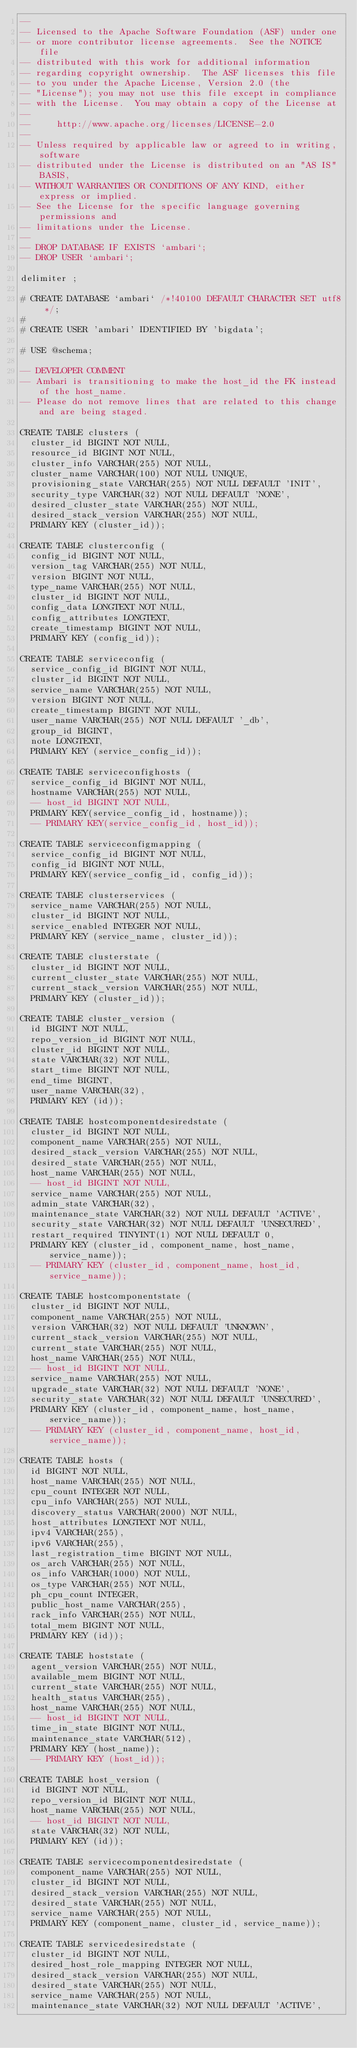<code> <loc_0><loc_0><loc_500><loc_500><_SQL_>--
-- Licensed to the Apache Software Foundation (ASF) under one
-- or more contributor license agreements.  See the NOTICE file
-- distributed with this work for additional information
-- regarding copyright ownership.  The ASF licenses this file
-- to you under the Apache License, Version 2.0 (the
-- "License"); you may not use this file except in compliance
-- with the License.  You may obtain a copy of the License at
--
--     http://www.apache.org/licenses/LICENSE-2.0
--
-- Unless required by applicable law or agreed to in writing, software
-- distributed under the License is distributed on an "AS IS" BASIS,
-- WITHOUT WARRANTIES OR CONDITIONS OF ANY KIND, either express or implied.
-- See the License for the specific language governing permissions and
-- limitations under the License.
--
-- DROP DATABASE IF EXISTS `ambari`;
-- DROP USER `ambari`;

delimiter ;

# CREATE DATABASE `ambari` /*!40100 DEFAULT CHARACTER SET utf8 */;
#
# CREATE USER 'ambari' IDENTIFIED BY 'bigdata';

# USE @schema;

-- DEVELOPER COMMENT
-- Ambari is transitioning to make the host_id the FK instead of the host_name.
-- Please do not remove lines that are related to this change and are being staged.

CREATE TABLE clusters (
  cluster_id BIGINT NOT NULL,
  resource_id BIGINT NOT NULL,
  cluster_info VARCHAR(255) NOT NULL,
  cluster_name VARCHAR(100) NOT NULL UNIQUE,
  provisioning_state VARCHAR(255) NOT NULL DEFAULT 'INIT',
  security_type VARCHAR(32) NOT NULL DEFAULT 'NONE',
  desired_cluster_state VARCHAR(255) NOT NULL,
  desired_stack_version VARCHAR(255) NOT NULL,
  PRIMARY KEY (cluster_id));

CREATE TABLE clusterconfig (
  config_id BIGINT NOT NULL,
  version_tag VARCHAR(255) NOT NULL,
  version BIGINT NOT NULL,
  type_name VARCHAR(255) NOT NULL,
  cluster_id BIGINT NOT NULL,
  config_data LONGTEXT NOT NULL,
  config_attributes LONGTEXT,
  create_timestamp BIGINT NOT NULL,
  PRIMARY KEY (config_id));

CREATE TABLE serviceconfig (
  service_config_id BIGINT NOT NULL,
  cluster_id BIGINT NOT NULL,
  service_name VARCHAR(255) NOT NULL,
  version BIGINT NOT NULL,
  create_timestamp BIGINT NOT NULL,
  user_name VARCHAR(255) NOT NULL DEFAULT '_db',
  group_id BIGINT,
  note LONGTEXT,
  PRIMARY KEY (service_config_id));

CREATE TABLE serviceconfighosts (
  service_config_id BIGINT NOT NULL,
  hostname VARCHAR(255) NOT NULL,
  -- host_id BIGINT NOT NULL,
  PRIMARY KEY(service_config_id, hostname));
  -- PRIMARY KEY(service_config_id, host_id));

CREATE TABLE serviceconfigmapping (
  service_config_id BIGINT NOT NULL,
  config_id BIGINT NOT NULL,
  PRIMARY KEY(service_config_id, config_id));

CREATE TABLE clusterservices (
  service_name VARCHAR(255) NOT NULL,
  cluster_id BIGINT NOT NULL,
  service_enabled INTEGER NOT NULL,
  PRIMARY KEY (service_name, cluster_id));

CREATE TABLE clusterstate (
  cluster_id BIGINT NOT NULL,
  current_cluster_state VARCHAR(255) NOT NULL,
  current_stack_version VARCHAR(255) NOT NULL,
  PRIMARY KEY (cluster_id));

CREATE TABLE cluster_version (
  id BIGINT NOT NULL,
  repo_version_id BIGINT NOT NULL,
  cluster_id BIGINT NOT NULL,
  state VARCHAR(32) NOT NULL,
  start_time BIGINT NOT NULL,
  end_time BIGINT,
  user_name VARCHAR(32),
  PRIMARY KEY (id));

CREATE TABLE hostcomponentdesiredstate (
  cluster_id BIGINT NOT NULL,
  component_name VARCHAR(255) NOT NULL,
  desired_stack_version VARCHAR(255) NOT NULL,
  desired_state VARCHAR(255) NOT NULL,
  host_name VARCHAR(255) NOT NULL,
  -- host_id BIGINT NOT NULL,
  service_name VARCHAR(255) NOT NULL,
  admin_state VARCHAR(32),
  maintenance_state VARCHAR(32) NOT NULL DEFAULT 'ACTIVE',
  security_state VARCHAR(32) NOT NULL DEFAULT 'UNSECURED',
  restart_required TINYINT(1) NOT NULL DEFAULT 0,
  PRIMARY KEY (cluster_id, component_name, host_name, service_name));
  -- PRIMARY KEY (cluster_id, component_name, host_id, service_name));

CREATE TABLE hostcomponentstate (
  cluster_id BIGINT NOT NULL,
  component_name VARCHAR(255) NOT NULL,
  version VARCHAR(32) NOT NULL DEFAULT 'UNKNOWN',
  current_stack_version VARCHAR(255) NOT NULL,
  current_state VARCHAR(255) NOT NULL,
  host_name VARCHAR(255) NOT NULL,
  -- host_id BIGINT NOT NULL,
  service_name VARCHAR(255) NOT NULL,
  upgrade_state VARCHAR(32) NOT NULL DEFAULT 'NONE',
  security_state VARCHAR(32) NOT NULL DEFAULT 'UNSECURED',
  PRIMARY KEY (cluster_id, component_name, host_name, service_name));
  -- PRIMARY KEY (cluster_id, component_name, host_id, service_name));

CREATE TABLE hosts (
  id BIGINT NOT NULL,
  host_name VARCHAR(255) NOT NULL,
  cpu_count INTEGER NOT NULL,
  cpu_info VARCHAR(255) NOT NULL,
  discovery_status VARCHAR(2000) NOT NULL,
  host_attributes LONGTEXT NOT NULL,
  ipv4 VARCHAR(255),
  ipv6 VARCHAR(255),
  last_registration_time BIGINT NOT NULL,
  os_arch VARCHAR(255) NOT NULL,
  os_info VARCHAR(1000) NOT NULL,
  os_type VARCHAR(255) NOT NULL,
  ph_cpu_count INTEGER,
  public_host_name VARCHAR(255),
  rack_info VARCHAR(255) NOT NULL,
  total_mem BIGINT NOT NULL,
  PRIMARY KEY (id));

CREATE TABLE hoststate (
  agent_version VARCHAR(255) NOT NULL,
  available_mem BIGINT NOT NULL,
  current_state VARCHAR(255) NOT NULL,
  health_status VARCHAR(255),
  host_name VARCHAR(255) NOT NULL,
  -- host_id BIGINT NOT NULL,
  time_in_state BIGINT NOT NULL,
  maintenance_state VARCHAR(512),
  PRIMARY KEY (host_name));
  -- PRIMARY KEY (host_id));

CREATE TABLE host_version (
  id BIGINT NOT NULL,
  repo_version_id BIGINT NOT NULL,
  host_name VARCHAR(255) NOT NULL,
  -- host_id BIGINT NOT NULL,
  state VARCHAR(32) NOT NULL,
  PRIMARY KEY (id));

CREATE TABLE servicecomponentdesiredstate (
  component_name VARCHAR(255) NOT NULL,
  cluster_id BIGINT NOT NULL,
  desired_stack_version VARCHAR(255) NOT NULL,
  desired_state VARCHAR(255) NOT NULL,
  service_name VARCHAR(255) NOT NULL,
  PRIMARY KEY (component_name, cluster_id, service_name));

CREATE TABLE servicedesiredstate (
  cluster_id BIGINT NOT NULL,
  desired_host_role_mapping INTEGER NOT NULL,
  desired_stack_version VARCHAR(255) NOT NULL,
  desired_state VARCHAR(255) NOT NULL,
  service_name VARCHAR(255) NOT NULL,
  maintenance_state VARCHAR(32) NOT NULL DEFAULT 'ACTIVE',</code> 